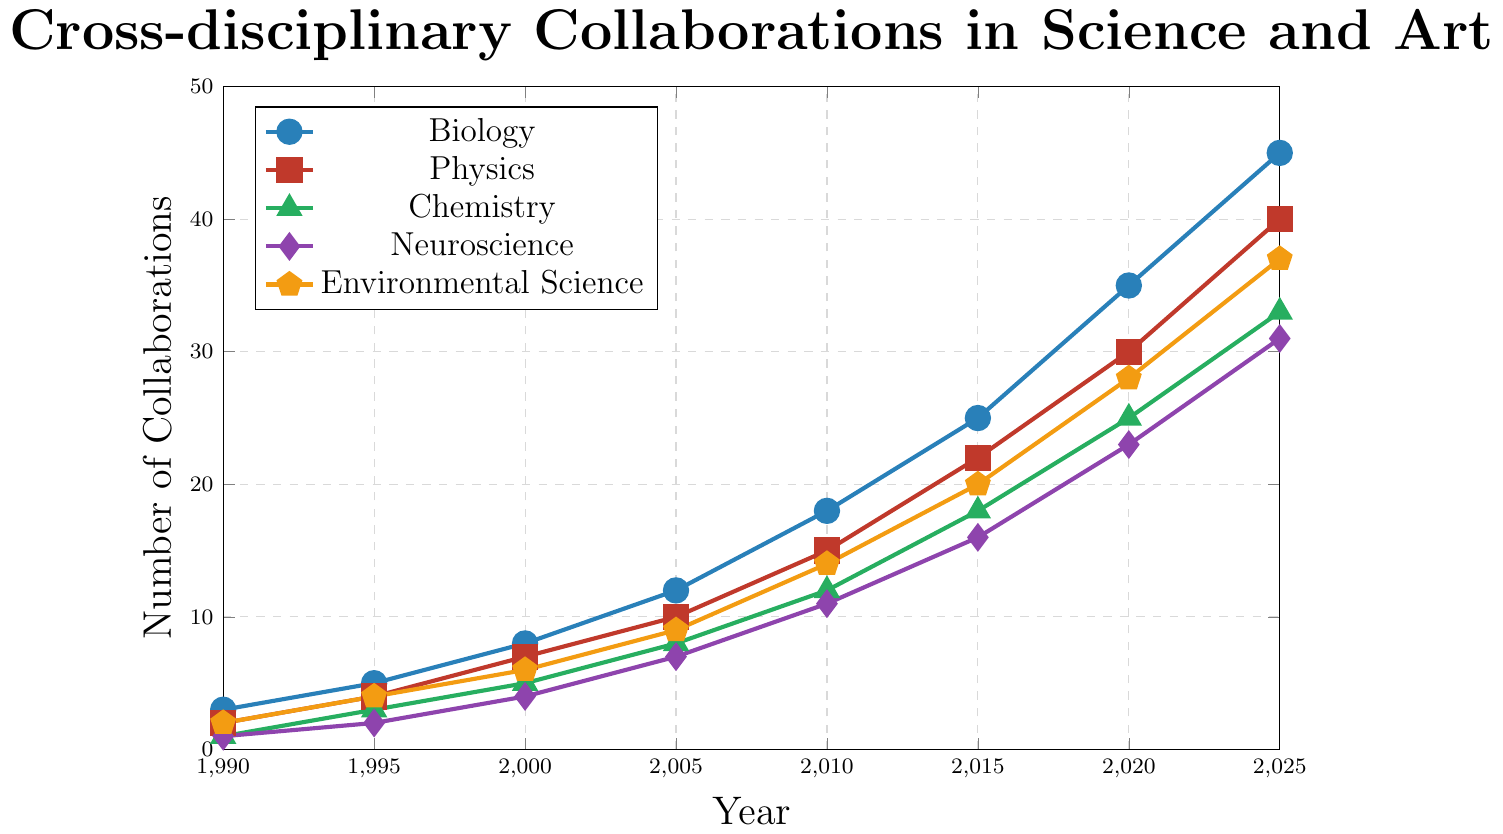What is the total number of collaborations in 2020 for all scientific fields combined? Add the number of collaborations for all fields in 2020: Biology (35), Physics (30), Chemistry (25), Neuroscience (23), Environmental Science (28). Sum: 35 + 30 + 25 + 23 + 28 = 141
Answer: 141 Which scientific field had the highest number of collaborations in 2015? Compare the number of collaborations in 2015 for each field: Biology (25), Physics (22), Chemistry (18), Neuroscience (16), Environmental Science (20). Biology had the highest number
Answer: Biology What is the trend in the number of collaborations for Chemistry from 1990 to 2025? Look at the number of collaborations for Chemistry over the years: 1990 (1), 1995 (3), 2000 (5), 2005 (8), 2010 (12), 2015 (18), 2020 (25), 2025 (33). The trend shows a steady increase over the years
Answer: Steady increase In which year did collaborations in Neuroscience surpass 10 for the first time? Check the values for Neuroscience: 1990 (1), 1995 (2), 2000 (4), 2005 (7), 2010 (11). Collaborations surpassed 10 in the year 2010
Answer: 2010 How many more collaborations were there in Biology compared to Physics in 2025? Subtract the number of collaborations in Physics (40) from those in Biology (45) in 2025: 45 - 40 = 5
Answer: 5 Between 2000 and 2010, which field saw the largest increase in collaborations? Calculate the increase from 2000 to 2010 for each field: Biology (18-8=10), Physics (15-7=8), Chemistry (12-5=7), Neuroscience (11-4=7), Environmental Science (14-6=8). Biology saw the largest increase
Answer: Biology What is the average number of collaborations for Environmental Science from 1990 to 2025? Sum the numbers for Environmental Science and divide by the number of years: (2 + 4 + 6 + 9 + 14 + 20 + 28 + 37) / 8 = 120 / 8 = 15
Answer: 15 How does the number of collaborations in Physics in 2000 compare to those in Neuroscience the same year? Compare the numbers for 2000: Physics (7), Neuroscience (4). Physics had more collaborations
Answer: Physics had more Which field experienced the smallest increase in the number of collaborations between 2015 and 2020? Calculate the increase from 2015 to 2020 for each field: Biology (35-25=10), Physics (30-22=8), Chemistry (25-18=7), Neuroscience (23-16=7), Environmental Science (28-20=8). Both Chemistry and Neuroscience had the smallest increase
Answer: Chemistry and Neuroscience 